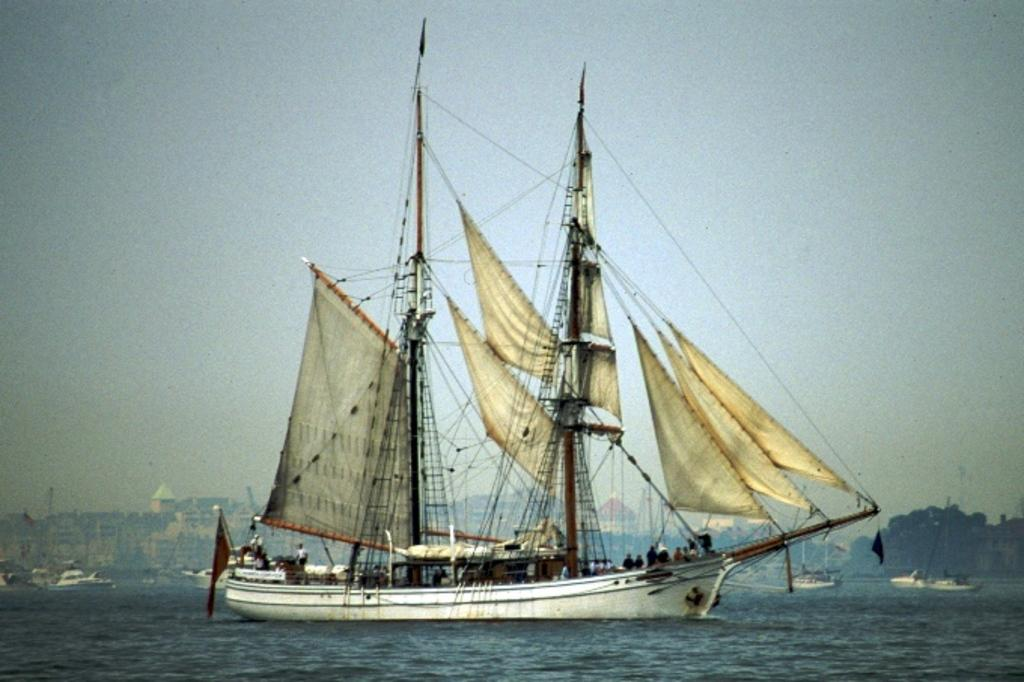What type of vehicle is present in the image? There is a sailboat in the image. Are there any other similar vehicles in the image? Yes, there are other boats in the image. What is the location of the boats in the image? The boats are floating on water. What can be seen in the background of the image? There are buildings and trees in the background of the image. What is the color of the sky in the image? The sky is pale blue in color. What type of skin condition can be seen on the sailboat in the image? There is no skin condition present on the sailboat, as it is an inanimate object. 